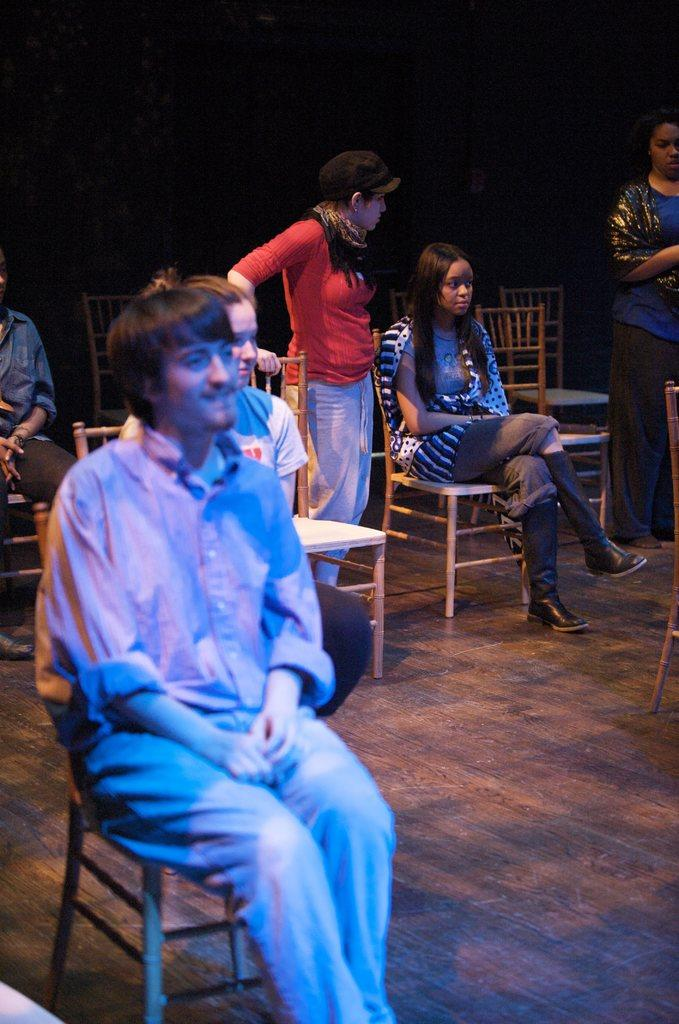What are the people in the image doing? The people in the image are sitting on chairs. Are there any other people in the image besides those sitting? Yes, there are two people standing in the image. What type of flooring is visible in the image? The floor appears to be wooden. How would you describe the lighting in the image? The background of the image is dark. What type of coal is being used to heat the room in the image? There is no coal present in the image, and the image does not depict a room being heated. 